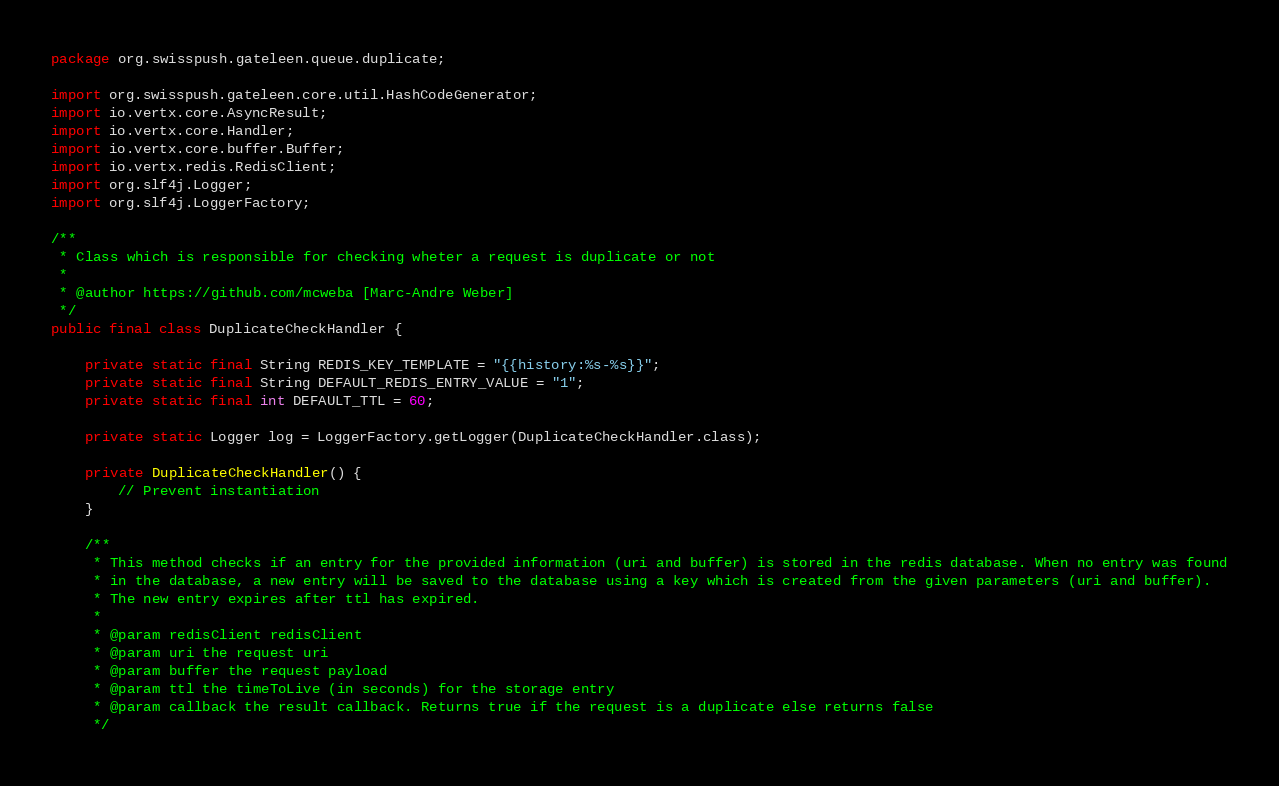Convert code to text. <code><loc_0><loc_0><loc_500><loc_500><_Java_>package org.swisspush.gateleen.queue.duplicate;

import org.swisspush.gateleen.core.util.HashCodeGenerator;
import io.vertx.core.AsyncResult;
import io.vertx.core.Handler;
import io.vertx.core.buffer.Buffer;
import io.vertx.redis.RedisClient;
import org.slf4j.Logger;
import org.slf4j.LoggerFactory;

/**
 * Class which is responsible for checking wheter a request is duplicate or not
 * 
 * @author https://github.com/mcweba [Marc-Andre Weber]
 */
public final class DuplicateCheckHandler {

    private static final String REDIS_KEY_TEMPLATE = "{{history:%s-%s}}";
    private static final String DEFAULT_REDIS_ENTRY_VALUE = "1";
    private static final int DEFAULT_TTL = 60;

    private static Logger log = LoggerFactory.getLogger(DuplicateCheckHandler.class);

    private DuplicateCheckHandler() {
        // Prevent instantiation
    }

    /**
     * This method checks if an entry for the provided information (uri and buffer) is stored in the redis database. When no entry was found
     * in the database, a new entry will be saved to the database using a key which is created from the given parameters (uri and buffer).
     * The new entry expires after ttl has expired.
     * 
     * @param redisClient redisClient
     * @param uri the request uri
     * @param buffer the request payload
     * @param ttl the timeToLive (in seconds) for the storage entry
     * @param callback the result callback. Returns true if the request is a duplicate else returns false
     */</code> 